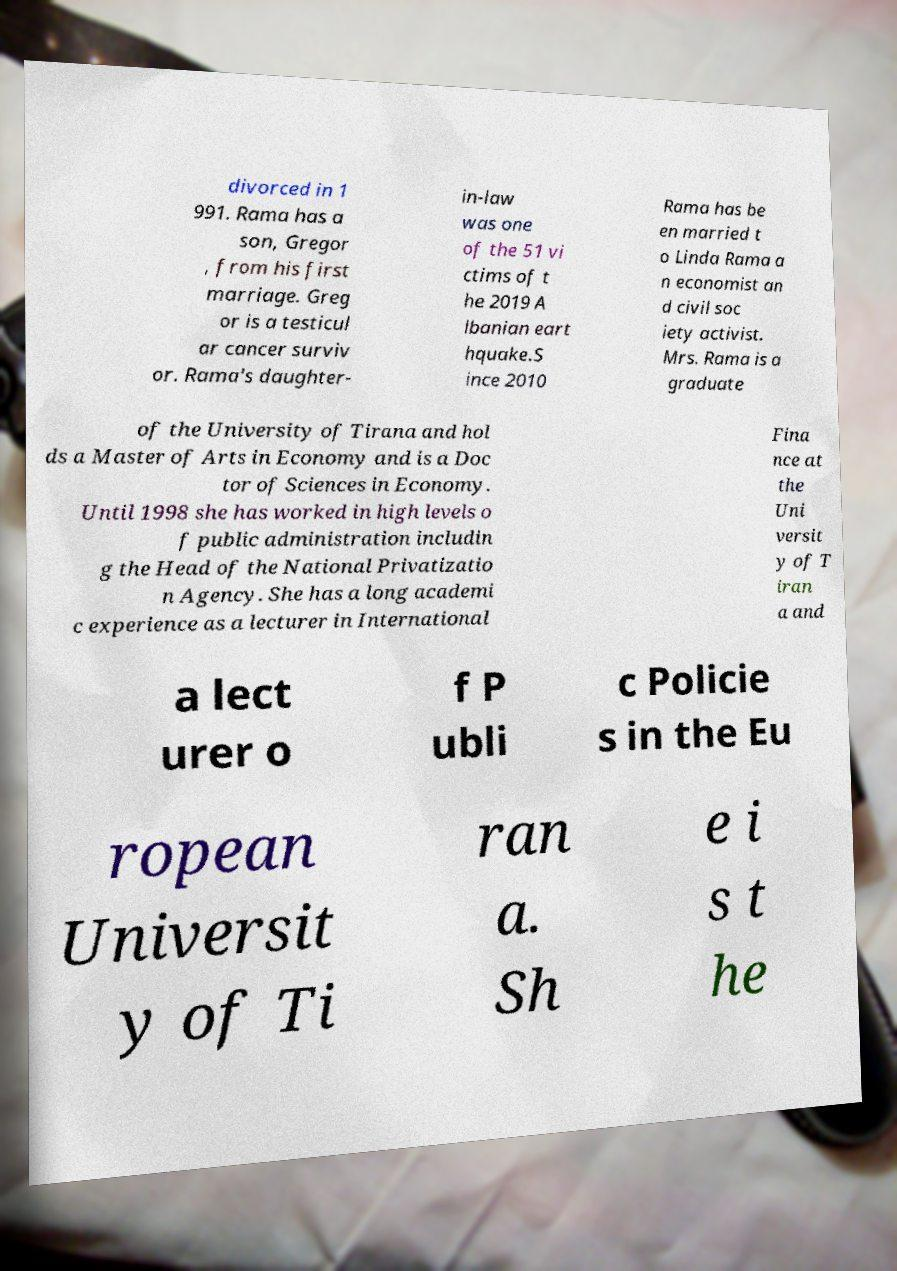For documentation purposes, I need the text within this image transcribed. Could you provide that? divorced in 1 991. Rama has a son, Gregor , from his first marriage. Greg or is a testicul ar cancer surviv or. Rama's daughter- in-law was one of the 51 vi ctims of t he 2019 A lbanian eart hquake.S ince 2010 Rama has be en married t o Linda Rama a n economist an d civil soc iety activist. Mrs. Rama is a graduate of the University of Tirana and hol ds a Master of Arts in Economy and is a Doc tor of Sciences in Economy. Until 1998 she has worked in high levels o f public administration includin g the Head of the National Privatizatio n Agency. She has a long academi c experience as a lecturer in International Fina nce at the Uni versit y of T iran a and a lect urer o f P ubli c Policie s in the Eu ropean Universit y of Ti ran a. Sh e i s t he 